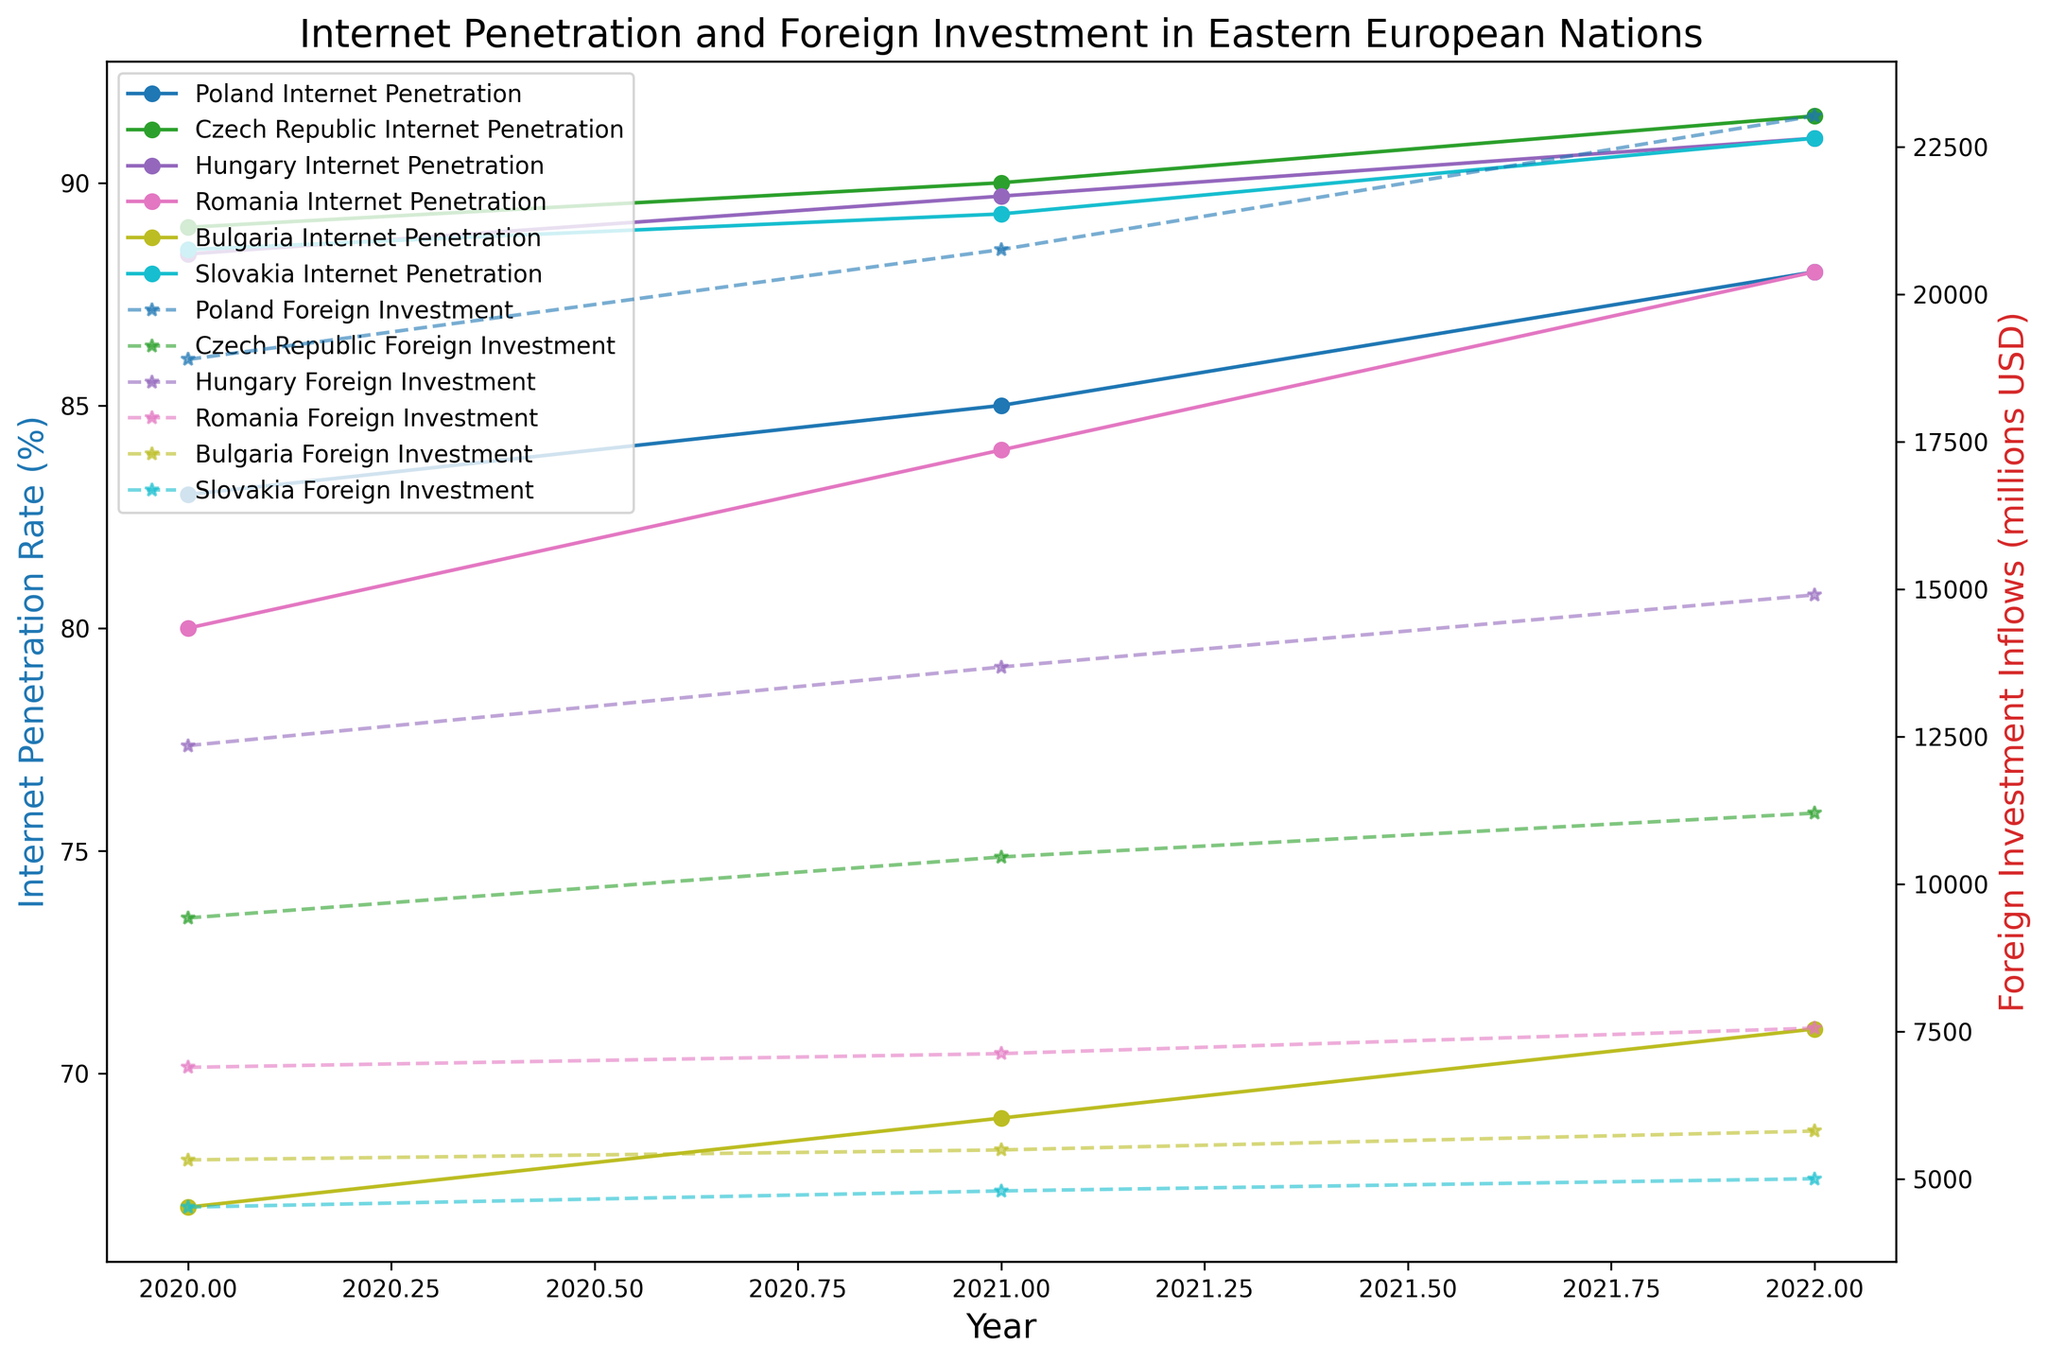What is the trend in Poland's Internet Penetration Rate from 2020 to 2022? From the figure, observe the markers representing Poland's Internet Penetration Rate over the years. The markers indicate an increase from 83.0% in 2020 to 88.0% in 2022.
Answer: Increasing Which country had the highest Internet Penetration Rate in 2022? By comparing the highest markers representing Internet Penetration Rates across countries in 2022, the Czech Republic has the highest at 91.5%.
Answer: Czech Republic Between Hungary and Romania, which experienced a greater increase in Foreign investment inflows from 2020 to 2022? Calculate the difference in Foreign Investment Inflows for both countries between 2020 and 2022. For Hungary, it's 14900 - 12345 = 2555 million USD. For Romania, it's 7555 - 6890 = 665 million USD. Hungary has a greater increase.
Answer: Hungary In which year did Slovakia's Foreign Investment Inflows exceed 4500 million USD? By examining the markers for Slovakia's Foreign Investment Inflows, in 2020 the value is 4520 million USD and in subsequent years 4795 and 5002 million USD, all values are above 4500 million.
Answer: 2020, 2021, and 2022 What is the difference in Internet Penetration Rates between Bulgaria and Romania in 2022? Compare the markers representing Internet Penetration Rates of Bulgaria and Romania in 2022. For Bulgaria, it's 71.0% and for Romania, it's 88.0%. The difference is 88.0% - 71.0% = 17.0%.
Answer: 17.0% Which country showed the most consistent increase in both Internet Penetration Rate and Foreign Investment Inflows from 2020 to 2022? Review the plotted lines for each country. The Czech Republic's lines for both Internet Penetration Rate and Foreign Investment Inflows consistently show a smooth increase each year from 2020 to 2022.
Answer: Czech Republic By how many percentage points did Romania's Internet Penetration Rate increase from 2020 to 2021? Calculate the difference between Internet Penetration Rates for Romania in 2021 (84.0%) and 2020 (80.0%). The increase is 84.0% - 80.0% = 4.0 percentage points.
Answer: 4.0 Compare Poland's Foreign Investment Inflows in 2020 and Bulgaria's Foreign Investment Inflows in 2022. Which is higher? Look at the markers for Poland in 2020 which show 18892 million USD and for Bulgaria in 2022 which show 5810 million USD. Poland's Foreign Investment Inflows are higher.
Answer: Poland What are the respective colors used to represent Hungary and Slovakia's Internet Penetration Rates in the figure? Identify the colors of the plotted lines for Hungary and Slovakia's Internet Penetration Rates. Hungary is designated a specific color and Slovakia another, distinguishable from each other and other countries.
Answer: Hungary: one specific color from the tab10 colormap, Slovakia: another specific color Which country has the smallest Foreign Investment Inflows in 2022 and how much is it? Check the final year's markers for Foreign Investment Inflows of all countries. Bulgaria, with 5810 million USD, is the smallest among them for 2022.
Answer: Bulgaria, 5810 million USD 